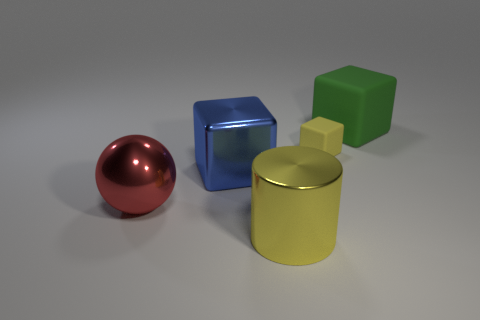What is the shape of the thing that is in front of the large blue block and behind the large shiny cylinder? The object situated directly in front of the large blue block and behind the large shiny cylinder is a perfect example of a sphere, exhibiting a uniformly round shape. 